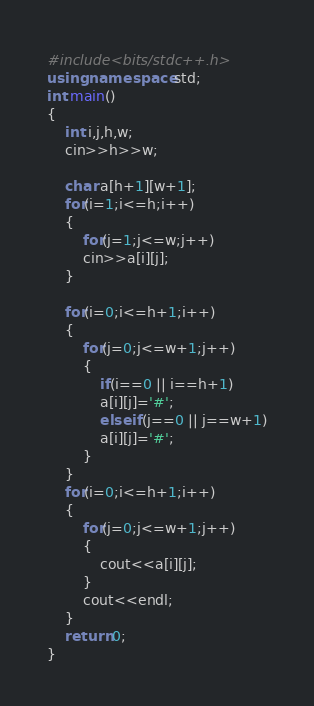<code> <loc_0><loc_0><loc_500><loc_500><_C++_>#include<bits/stdc++.h>
using namespace std;
int main()
{
    int i,j,h,w;
    cin>>h>>w;
    
    char a[h+1][w+1];
    for(i=1;i<=h;i++)
    {
        for(j=1;j<=w;j++)
        cin>>a[i][j];
    }

    for(i=0;i<=h+1;i++)
    {
        for(j=0;j<=w+1;j++)
        {
            if(i==0 || i==h+1)
            a[i][j]='#';
            else if(j==0 || j==w+1)
            a[i][j]='#';
        }
    }
    for(i=0;i<=h+1;i++)
    {
        for(j=0;j<=w+1;j++)
        {
            cout<<a[i][j];
        }
        cout<<endl;
    }
    return 0;
}</code> 